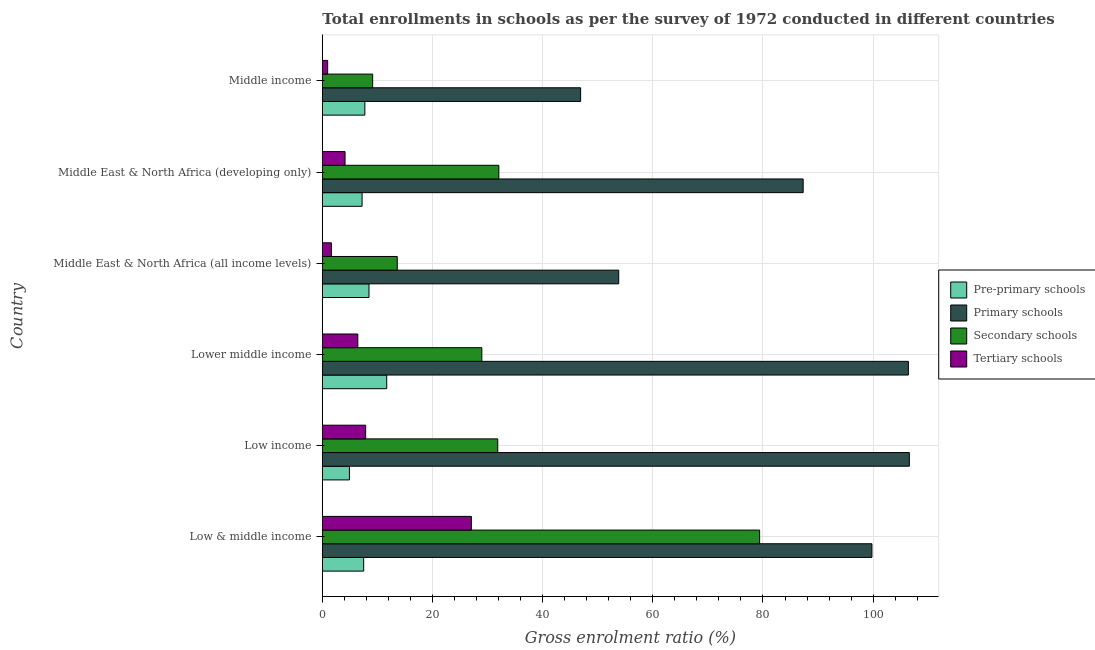How many different coloured bars are there?
Your answer should be very brief. 4. Are the number of bars on each tick of the Y-axis equal?
Your answer should be compact. Yes. How many bars are there on the 5th tick from the bottom?
Provide a short and direct response. 4. What is the label of the 3rd group of bars from the top?
Provide a succinct answer. Middle East & North Africa (all income levels). In how many cases, is the number of bars for a given country not equal to the number of legend labels?
Your answer should be compact. 0. What is the gross enrolment ratio in secondary schools in Middle income?
Provide a succinct answer. 9.14. Across all countries, what is the maximum gross enrolment ratio in primary schools?
Offer a terse response. 106.58. Across all countries, what is the minimum gross enrolment ratio in secondary schools?
Provide a succinct answer. 9.14. In which country was the gross enrolment ratio in tertiary schools maximum?
Give a very brief answer. Low & middle income. What is the total gross enrolment ratio in primary schools in the graph?
Offer a terse response. 500.77. What is the difference between the gross enrolment ratio in secondary schools in Low & middle income and that in Lower middle income?
Make the answer very short. 50.44. What is the difference between the gross enrolment ratio in primary schools in Lower middle income and the gross enrolment ratio in secondary schools in Low income?
Make the answer very short. 74.55. What is the average gross enrolment ratio in primary schools per country?
Your answer should be compact. 83.46. What is the difference between the gross enrolment ratio in primary schools and gross enrolment ratio in secondary schools in Low income?
Give a very brief answer. 74.73. In how many countries, is the gross enrolment ratio in pre-primary schools greater than 80 %?
Offer a terse response. 0. What is the ratio of the gross enrolment ratio in secondary schools in Low income to that in Middle East & North Africa (all income levels)?
Offer a very short reply. 2.34. What is the difference between the highest and the second highest gross enrolment ratio in primary schools?
Offer a terse response. 0.17. What is the difference between the highest and the lowest gross enrolment ratio in primary schools?
Your answer should be compact. 59.68. In how many countries, is the gross enrolment ratio in primary schools greater than the average gross enrolment ratio in primary schools taken over all countries?
Your response must be concise. 4. Is the sum of the gross enrolment ratio in pre-primary schools in Low income and Middle East & North Africa (all income levels) greater than the maximum gross enrolment ratio in secondary schools across all countries?
Ensure brevity in your answer.  No. What does the 3rd bar from the top in Lower middle income represents?
Provide a succinct answer. Primary schools. What does the 4th bar from the bottom in Middle income represents?
Provide a short and direct response. Tertiary schools. Is it the case that in every country, the sum of the gross enrolment ratio in pre-primary schools and gross enrolment ratio in primary schools is greater than the gross enrolment ratio in secondary schools?
Your answer should be very brief. Yes. How many bars are there?
Keep it short and to the point. 24. Are all the bars in the graph horizontal?
Your answer should be very brief. Yes. How many countries are there in the graph?
Keep it short and to the point. 6. What is the difference between two consecutive major ticks on the X-axis?
Keep it short and to the point. 20. Are the values on the major ticks of X-axis written in scientific E-notation?
Provide a short and direct response. No. Does the graph contain grids?
Make the answer very short. Yes. Where does the legend appear in the graph?
Ensure brevity in your answer.  Center right. How are the legend labels stacked?
Provide a succinct answer. Vertical. What is the title of the graph?
Provide a succinct answer. Total enrollments in schools as per the survey of 1972 conducted in different countries. What is the Gross enrolment ratio (%) of Pre-primary schools in Low & middle income?
Your answer should be compact. 7.51. What is the Gross enrolment ratio (%) of Primary schools in Low & middle income?
Provide a succinct answer. 99.78. What is the Gross enrolment ratio (%) of Secondary schools in Low & middle income?
Provide a succinct answer. 79.39. What is the Gross enrolment ratio (%) in Tertiary schools in Low & middle income?
Ensure brevity in your answer.  27.06. What is the Gross enrolment ratio (%) in Pre-primary schools in Low income?
Provide a short and direct response. 4.92. What is the Gross enrolment ratio (%) of Primary schools in Low income?
Provide a succinct answer. 106.58. What is the Gross enrolment ratio (%) of Secondary schools in Low income?
Offer a very short reply. 31.85. What is the Gross enrolment ratio (%) of Tertiary schools in Low income?
Provide a short and direct response. 7.87. What is the Gross enrolment ratio (%) of Pre-primary schools in Lower middle income?
Your answer should be compact. 11.69. What is the Gross enrolment ratio (%) of Primary schools in Lower middle income?
Provide a succinct answer. 106.4. What is the Gross enrolment ratio (%) in Secondary schools in Lower middle income?
Give a very brief answer. 28.95. What is the Gross enrolment ratio (%) in Tertiary schools in Lower middle income?
Your answer should be very brief. 6.44. What is the Gross enrolment ratio (%) in Pre-primary schools in Middle East & North Africa (all income levels)?
Make the answer very short. 8.47. What is the Gross enrolment ratio (%) of Primary schools in Middle East & North Africa (all income levels)?
Keep it short and to the point. 53.81. What is the Gross enrolment ratio (%) of Secondary schools in Middle East & North Africa (all income levels)?
Keep it short and to the point. 13.61. What is the Gross enrolment ratio (%) of Tertiary schools in Middle East & North Africa (all income levels)?
Ensure brevity in your answer.  1.65. What is the Gross enrolment ratio (%) in Pre-primary schools in Middle East & North Africa (developing only)?
Make the answer very short. 7.22. What is the Gross enrolment ratio (%) in Primary schools in Middle East & North Africa (developing only)?
Give a very brief answer. 87.3. What is the Gross enrolment ratio (%) of Secondary schools in Middle East & North Africa (developing only)?
Ensure brevity in your answer.  32.04. What is the Gross enrolment ratio (%) in Tertiary schools in Middle East & North Africa (developing only)?
Offer a very short reply. 4.13. What is the Gross enrolment ratio (%) in Pre-primary schools in Middle income?
Your answer should be very brief. 7.72. What is the Gross enrolment ratio (%) of Primary schools in Middle income?
Give a very brief answer. 46.89. What is the Gross enrolment ratio (%) in Secondary schools in Middle income?
Your response must be concise. 9.14. What is the Gross enrolment ratio (%) in Tertiary schools in Middle income?
Offer a very short reply. 0.97. Across all countries, what is the maximum Gross enrolment ratio (%) in Pre-primary schools?
Provide a short and direct response. 11.69. Across all countries, what is the maximum Gross enrolment ratio (%) in Primary schools?
Offer a terse response. 106.58. Across all countries, what is the maximum Gross enrolment ratio (%) in Secondary schools?
Offer a terse response. 79.39. Across all countries, what is the maximum Gross enrolment ratio (%) of Tertiary schools?
Offer a terse response. 27.06. Across all countries, what is the minimum Gross enrolment ratio (%) in Pre-primary schools?
Make the answer very short. 4.92. Across all countries, what is the minimum Gross enrolment ratio (%) in Primary schools?
Give a very brief answer. 46.89. Across all countries, what is the minimum Gross enrolment ratio (%) in Secondary schools?
Your answer should be very brief. 9.14. Across all countries, what is the minimum Gross enrolment ratio (%) of Tertiary schools?
Provide a short and direct response. 0.97. What is the total Gross enrolment ratio (%) in Pre-primary schools in the graph?
Your response must be concise. 47.53. What is the total Gross enrolment ratio (%) of Primary schools in the graph?
Your response must be concise. 500.77. What is the total Gross enrolment ratio (%) of Secondary schools in the graph?
Make the answer very short. 194.99. What is the total Gross enrolment ratio (%) in Tertiary schools in the graph?
Offer a terse response. 48.12. What is the difference between the Gross enrolment ratio (%) of Pre-primary schools in Low & middle income and that in Low income?
Offer a very short reply. 2.59. What is the difference between the Gross enrolment ratio (%) of Primary schools in Low & middle income and that in Low income?
Your response must be concise. -6.79. What is the difference between the Gross enrolment ratio (%) of Secondary schools in Low & middle income and that in Low income?
Keep it short and to the point. 47.54. What is the difference between the Gross enrolment ratio (%) of Tertiary schools in Low & middle income and that in Low income?
Your answer should be compact. 19.2. What is the difference between the Gross enrolment ratio (%) of Pre-primary schools in Low & middle income and that in Lower middle income?
Provide a succinct answer. -4.18. What is the difference between the Gross enrolment ratio (%) of Primary schools in Low & middle income and that in Lower middle income?
Your answer should be compact. -6.62. What is the difference between the Gross enrolment ratio (%) of Secondary schools in Low & middle income and that in Lower middle income?
Offer a terse response. 50.44. What is the difference between the Gross enrolment ratio (%) of Tertiary schools in Low & middle income and that in Lower middle income?
Provide a short and direct response. 20.62. What is the difference between the Gross enrolment ratio (%) of Pre-primary schools in Low & middle income and that in Middle East & North Africa (all income levels)?
Provide a short and direct response. -0.96. What is the difference between the Gross enrolment ratio (%) in Primary schools in Low & middle income and that in Middle East & North Africa (all income levels)?
Provide a short and direct response. 45.97. What is the difference between the Gross enrolment ratio (%) in Secondary schools in Low & middle income and that in Middle East & North Africa (all income levels)?
Provide a succinct answer. 65.79. What is the difference between the Gross enrolment ratio (%) in Tertiary schools in Low & middle income and that in Middle East & North Africa (all income levels)?
Provide a succinct answer. 25.42. What is the difference between the Gross enrolment ratio (%) in Pre-primary schools in Low & middle income and that in Middle East & North Africa (developing only)?
Offer a very short reply. 0.29. What is the difference between the Gross enrolment ratio (%) in Primary schools in Low & middle income and that in Middle East & North Africa (developing only)?
Offer a terse response. 12.48. What is the difference between the Gross enrolment ratio (%) in Secondary schools in Low & middle income and that in Middle East & North Africa (developing only)?
Ensure brevity in your answer.  47.35. What is the difference between the Gross enrolment ratio (%) in Tertiary schools in Low & middle income and that in Middle East & North Africa (developing only)?
Make the answer very short. 22.94. What is the difference between the Gross enrolment ratio (%) in Pre-primary schools in Low & middle income and that in Middle income?
Your answer should be compact. -0.21. What is the difference between the Gross enrolment ratio (%) of Primary schools in Low & middle income and that in Middle income?
Give a very brief answer. 52.89. What is the difference between the Gross enrolment ratio (%) of Secondary schools in Low & middle income and that in Middle income?
Your answer should be compact. 70.26. What is the difference between the Gross enrolment ratio (%) of Tertiary schools in Low & middle income and that in Middle income?
Your response must be concise. 26.1. What is the difference between the Gross enrolment ratio (%) in Pre-primary schools in Low income and that in Lower middle income?
Keep it short and to the point. -6.77. What is the difference between the Gross enrolment ratio (%) in Primary schools in Low income and that in Lower middle income?
Make the answer very short. 0.17. What is the difference between the Gross enrolment ratio (%) of Secondary schools in Low income and that in Lower middle income?
Give a very brief answer. 2.9. What is the difference between the Gross enrolment ratio (%) of Tertiary schools in Low income and that in Lower middle income?
Your response must be concise. 1.43. What is the difference between the Gross enrolment ratio (%) of Pre-primary schools in Low income and that in Middle East & North Africa (all income levels)?
Provide a short and direct response. -3.55. What is the difference between the Gross enrolment ratio (%) in Primary schools in Low income and that in Middle East & North Africa (all income levels)?
Make the answer very short. 52.77. What is the difference between the Gross enrolment ratio (%) in Secondary schools in Low income and that in Middle East & North Africa (all income levels)?
Ensure brevity in your answer.  18.24. What is the difference between the Gross enrolment ratio (%) of Tertiary schools in Low income and that in Middle East & North Africa (all income levels)?
Your response must be concise. 6.22. What is the difference between the Gross enrolment ratio (%) of Pre-primary schools in Low income and that in Middle East & North Africa (developing only)?
Offer a very short reply. -2.3. What is the difference between the Gross enrolment ratio (%) of Primary schools in Low income and that in Middle East & North Africa (developing only)?
Give a very brief answer. 19.28. What is the difference between the Gross enrolment ratio (%) in Secondary schools in Low income and that in Middle East & North Africa (developing only)?
Your response must be concise. -0.2. What is the difference between the Gross enrolment ratio (%) in Tertiary schools in Low income and that in Middle East & North Africa (developing only)?
Give a very brief answer. 3.74. What is the difference between the Gross enrolment ratio (%) in Pre-primary schools in Low income and that in Middle income?
Keep it short and to the point. -2.8. What is the difference between the Gross enrolment ratio (%) in Primary schools in Low income and that in Middle income?
Your response must be concise. 59.68. What is the difference between the Gross enrolment ratio (%) in Secondary schools in Low income and that in Middle income?
Your response must be concise. 22.71. What is the difference between the Gross enrolment ratio (%) of Tertiary schools in Low income and that in Middle income?
Your response must be concise. 6.9. What is the difference between the Gross enrolment ratio (%) of Pre-primary schools in Lower middle income and that in Middle East & North Africa (all income levels)?
Offer a very short reply. 3.22. What is the difference between the Gross enrolment ratio (%) in Primary schools in Lower middle income and that in Middle East & North Africa (all income levels)?
Give a very brief answer. 52.59. What is the difference between the Gross enrolment ratio (%) in Secondary schools in Lower middle income and that in Middle East & North Africa (all income levels)?
Keep it short and to the point. 15.35. What is the difference between the Gross enrolment ratio (%) in Tertiary schools in Lower middle income and that in Middle East & North Africa (all income levels)?
Your answer should be very brief. 4.8. What is the difference between the Gross enrolment ratio (%) of Pre-primary schools in Lower middle income and that in Middle East & North Africa (developing only)?
Your response must be concise. 4.48. What is the difference between the Gross enrolment ratio (%) of Primary schools in Lower middle income and that in Middle East & North Africa (developing only)?
Your answer should be compact. 19.1. What is the difference between the Gross enrolment ratio (%) of Secondary schools in Lower middle income and that in Middle East & North Africa (developing only)?
Your answer should be compact. -3.09. What is the difference between the Gross enrolment ratio (%) of Tertiary schools in Lower middle income and that in Middle East & North Africa (developing only)?
Keep it short and to the point. 2.32. What is the difference between the Gross enrolment ratio (%) in Pre-primary schools in Lower middle income and that in Middle income?
Make the answer very short. 3.97. What is the difference between the Gross enrolment ratio (%) in Primary schools in Lower middle income and that in Middle income?
Ensure brevity in your answer.  59.51. What is the difference between the Gross enrolment ratio (%) of Secondary schools in Lower middle income and that in Middle income?
Offer a terse response. 19.82. What is the difference between the Gross enrolment ratio (%) of Tertiary schools in Lower middle income and that in Middle income?
Offer a very short reply. 5.47. What is the difference between the Gross enrolment ratio (%) in Pre-primary schools in Middle East & North Africa (all income levels) and that in Middle East & North Africa (developing only)?
Offer a terse response. 1.26. What is the difference between the Gross enrolment ratio (%) of Primary schools in Middle East & North Africa (all income levels) and that in Middle East & North Africa (developing only)?
Make the answer very short. -33.49. What is the difference between the Gross enrolment ratio (%) of Secondary schools in Middle East & North Africa (all income levels) and that in Middle East & North Africa (developing only)?
Offer a very short reply. -18.44. What is the difference between the Gross enrolment ratio (%) of Tertiary schools in Middle East & North Africa (all income levels) and that in Middle East & North Africa (developing only)?
Your answer should be very brief. -2.48. What is the difference between the Gross enrolment ratio (%) of Pre-primary schools in Middle East & North Africa (all income levels) and that in Middle income?
Provide a short and direct response. 0.75. What is the difference between the Gross enrolment ratio (%) in Primary schools in Middle East & North Africa (all income levels) and that in Middle income?
Your answer should be compact. 6.92. What is the difference between the Gross enrolment ratio (%) of Secondary schools in Middle East & North Africa (all income levels) and that in Middle income?
Your answer should be very brief. 4.47. What is the difference between the Gross enrolment ratio (%) in Tertiary schools in Middle East & North Africa (all income levels) and that in Middle income?
Ensure brevity in your answer.  0.68. What is the difference between the Gross enrolment ratio (%) of Pre-primary schools in Middle East & North Africa (developing only) and that in Middle income?
Your answer should be very brief. -0.51. What is the difference between the Gross enrolment ratio (%) of Primary schools in Middle East & North Africa (developing only) and that in Middle income?
Give a very brief answer. 40.4. What is the difference between the Gross enrolment ratio (%) in Secondary schools in Middle East & North Africa (developing only) and that in Middle income?
Make the answer very short. 22.91. What is the difference between the Gross enrolment ratio (%) in Tertiary schools in Middle East & North Africa (developing only) and that in Middle income?
Your answer should be very brief. 3.16. What is the difference between the Gross enrolment ratio (%) of Pre-primary schools in Low & middle income and the Gross enrolment ratio (%) of Primary schools in Low income?
Your response must be concise. -99.07. What is the difference between the Gross enrolment ratio (%) of Pre-primary schools in Low & middle income and the Gross enrolment ratio (%) of Secondary schools in Low income?
Your answer should be compact. -24.34. What is the difference between the Gross enrolment ratio (%) of Pre-primary schools in Low & middle income and the Gross enrolment ratio (%) of Tertiary schools in Low income?
Make the answer very short. -0.36. What is the difference between the Gross enrolment ratio (%) of Primary schools in Low & middle income and the Gross enrolment ratio (%) of Secondary schools in Low income?
Provide a succinct answer. 67.93. What is the difference between the Gross enrolment ratio (%) in Primary schools in Low & middle income and the Gross enrolment ratio (%) in Tertiary schools in Low income?
Your response must be concise. 91.92. What is the difference between the Gross enrolment ratio (%) in Secondary schools in Low & middle income and the Gross enrolment ratio (%) in Tertiary schools in Low income?
Offer a very short reply. 71.53. What is the difference between the Gross enrolment ratio (%) of Pre-primary schools in Low & middle income and the Gross enrolment ratio (%) of Primary schools in Lower middle income?
Your answer should be compact. -98.89. What is the difference between the Gross enrolment ratio (%) in Pre-primary schools in Low & middle income and the Gross enrolment ratio (%) in Secondary schools in Lower middle income?
Your answer should be very brief. -21.44. What is the difference between the Gross enrolment ratio (%) in Pre-primary schools in Low & middle income and the Gross enrolment ratio (%) in Tertiary schools in Lower middle income?
Keep it short and to the point. 1.07. What is the difference between the Gross enrolment ratio (%) of Primary schools in Low & middle income and the Gross enrolment ratio (%) of Secondary schools in Lower middle income?
Offer a terse response. 70.83. What is the difference between the Gross enrolment ratio (%) of Primary schools in Low & middle income and the Gross enrolment ratio (%) of Tertiary schools in Lower middle income?
Your answer should be very brief. 93.34. What is the difference between the Gross enrolment ratio (%) of Secondary schools in Low & middle income and the Gross enrolment ratio (%) of Tertiary schools in Lower middle income?
Ensure brevity in your answer.  72.95. What is the difference between the Gross enrolment ratio (%) of Pre-primary schools in Low & middle income and the Gross enrolment ratio (%) of Primary schools in Middle East & North Africa (all income levels)?
Your response must be concise. -46.3. What is the difference between the Gross enrolment ratio (%) of Pre-primary schools in Low & middle income and the Gross enrolment ratio (%) of Secondary schools in Middle East & North Africa (all income levels)?
Your response must be concise. -6.1. What is the difference between the Gross enrolment ratio (%) in Pre-primary schools in Low & middle income and the Gross enrolment ratio (%) in Tertiary schools in Middle East & North Africa (all income levels)?
Provide a succinct answer. 5.86. What is the difference between the Gross enrolment ratio (%) of Primary schools in Low & middle income and the Gross enrolment ratio (%) of Secondary schools in Middle East & North Africa (all income levels)?
Your answer should be very brief. 86.18. What is the difference between the Gross enrolment ratio (%) of Primary schools in Low & middle income and the Gross enrolment ratio (%) of Tertiary schools in Middle East & North Africa (all income levels)?
Your answer should be compact. 98.14. What is the difference between the Gross enrolment ratio (%) of Secondary schools in Low & middle income and the Gross enrolment ratio (%) of Tertiary schools in Middle East & North Africa (all income levels)?
Provide a short and direct response. 77.75. What is the difference between the Gross enrolment ratio (%) of Pre-primary schools in Low & middle income and the Gross enrolment ratio (%) of Primary schools in Middle East & North Africa (developing only)?
Offer a terse response. -79.79. What is the difference between the Gross enrolment ratio (%) of Pre-primary schools in Low & middle income and the Gross enrolment ratio (%) of Secondary schools in Middle East & North Africa (developing only)?
Your response must be concise. -24.54. What is the difference between the Gross enrolment ratio (%) in Pre-primary schools in Low & middle income and the Gross enrolment ratio (%) in Tertiary schools in Middle East & North Africa (developing only)?
Your answer should be very brief. 3.38. What is the difference between the Gross enrolment ratio (%) of Primary schools in Low & middle income and the Gross enrolment ratio (%) of Secondary schools in Middle East & North Africa (developing only)?
Give a very brief answer. 67.74. What is the difference between the Gross enrolment ratio (%) of Primary schools in Low & middle income and the Gross enrolment ratio (%) of Tertiary schools in Middle East & North Africa (developing only)?
Your response must be concise. 95.66. What is the difference between the Gross enrolment ratio (%) of Secondary schools in Low & middle income and the Gross enrolment ratio (%) of Tertiary schools in Middle East & North Africa (developing only)?
Make the answer very short. 75.27. What is the difference between the Gross enrolment ratio (%) of Pre-primary schools in Low & middle income and the Gross enrolment ratio (%) of Primary schools in Middle income?
Provide a succinct answer. -39.38. What is the difference between the Gross enrolment ratio (%) in Pre-primary schools in Low & middle income and the Gross enrolment ratio (%) in Secondary schools in Middle income?
Give a very brief answer. -1.63. What is the difference between the Gross enrolment ratio (%) of Pre-primary schools in Low & middle income and the Gross enrolment ratio (%) of Tertiary schools in Middle income?
Offer a terse response. 6.54. What is the difference between the Gross enrolment ratio (%) in Primary schools in Low & middle income and the Gross enrolment ratio (%) in Secondary schools in Middle income?
Offer a terse response. 90.64. What is the difference between the Gross enrolment ratio (%) in Primary schools in Low & middle income and the Gross enrolment ratio (%) in Tertiary schools in Middle income?
Your response must be concise. 98.81. What is the difference between the Gross enrolment ratio (%) of Secondary schools in Low & middle income and the Gross enrolment ratio (%) of Tertiary schools in Middle income?
Your response must be concise. 78.43. What is the difference between the Gross enrolment ratio (%) in Pre-primary schools in Low income and the Gross enrolment ratio (%) in Primary schools in Lower middle income?
Your answer should be very brief. -101.48. What is the difference between the Gross enrolment ratio (%) of Pre-primary schools in Low income and the Gross enrolment ratio (%) of Secondary schools in Lower middle income?
Your answer should be compact. -24.04. What is the difference between the Gross enrolment ratio (%) of Pre-primary schools in Low income and the Gross enrolment ratio (%) of Tertiary schools in Lower middle income?
Give a very brief answer. -1.52. What is the difference between the Gross enrolment ratio (%) in Primary schools in Low income and the Gross enrolment ratio (%) in Secondary schools in Lower middle income?
Offer a very short reply. 77.62. What is the difference between the Gross enrolment ratio (%) of Primary schools in Low income and the Gross enrolment ratio (%) of Tertiary schools in Lower middle income?
Your answer should be compact. 100.13. What is the difference between the Gross enrolment ratio (%) of Secondary schools in Low income and the Gross enrolment ratio (%) of Tertiary schools in Lower middle income?
Offer a terse response. 25.41. What is the difference between the Gross enrolment ratio (%) in Pre-primary schools in Low income and the Gross enrolment ratio (%) in Primary schools in Middle East & North Africa (all income levels)?
Keep it short and to the point. -48.89. What is the difference between the Gross enrolment ratio (%) in Pre-primary schools in Low income and the Gross enrolment ratio (%) in Secondary schools in Middle East & North Africa (all income levels)?
Make the answer very short. -8.69. What is the difference between the Gross enrolment ratio (%) of Pre-primary schools in Low income and the Gross enrolment ratio (%) of Tertiary schools in Middle East & North Africa (all income levels)?
Provide a short and direct response. 3.27. What is the difference between the Gross enrolment ratio (%) in Primary schools in Low income and the Gross enrolment ratio (%) in Secondary schools in Middle East & North Africa (all income levels)?
Offer a very short reply. 92.97. What is the difference between the Gross enrolment ratio (%) in Primary schools in Low income and the Gross enrolment ratio (%) in Tertiary schools in Middle East & North Africa (all income levels)?
Make the answer very short. 104.93. What is the difference between the Gross enrolment ratio (%) in Secondary schools in Low income and the Gross enrolment ratio (%) in Tertiary schools in Middle East & North Africa (all income levels)?
Your answer should be compact. 30.2. What is the difference between the Gross enrolment ratio (%) in Pre-primary schools in Low income and the Gross enrolment ratio (%) in Primary schools in Middle East & North Africa (developing only)?
Offer a very short reply. -82.38. What is the difference between the Gross enrolment ratio (%) of Pre-primary schools in Low income and the Gross enrolment ratio (%) of Secondary schools in Middle East & North Africa (developing only)?
Give a very brief answer. -27.13. What is the difference between the Gross enrolment ratio (%) of Pre-primary schools in Low income and the Gross enrolment ratio (%) of Tertiary schools in Middle East & North Africa (developing only)?
Make the answer very short. 0.79. What is the difference between the Gross enrolment ratio (%) in Primary schools in Low income and the Gross enrolment ratio (%) in Secondary schools in Middle East & North Africa (developing only)?
Give a very brief answer. 74.53. What is the difference between the Gross enrolment ratio (%) in Primary schools in Low income and the Gross enrolment ratio (%) in Tertiary schools in Middle East & North Africa (developing only)?
Give a very brief answer. 102.45. What is the difference between the Gross enrolment ratio (%) of Secondary schools in Low income and the Gross enrolment ratio (%) of Tertiary schools in Middle East & North Africa (developing only)?
Provide a short and direct response. 27.72. What is the difference between the Gross enrolment ratio (%) in Pre-primary schools in Low income and the Gross enrolment ratio (%) in Primary schools in Middle income?
Provide a succinct answer. -41.98. What is the difference between the Gross enrolment ratio (%) in Pre-primary schools in Low income and the Gross enrolment ratio (%) in Secondary schools in Middle income?
Your answer should be compact. -4.22. What is the difference between the Gross enrolment ratio (%) in Pre-primary schools in Low income and the Gross enrolment ratio (%) in Tertiary schools in Middle income?
Provide a short and direct response. 3.95. What is the difference between the Gross enrolment ratio (%) of Primary schools in Low income and the Gross enrolment ratio (%) of Secondary schools in Middle income?
Keep it short and to the point. 97.44. What is the difference between the Gross enrolment ratio (%) of Primary schools in Low income and the Gross enrolment ratio (%) of Tertiary schools in Middle income?
Provide a succinct answer. 105.61. What is the difference between the Gross enrolment ratio (%) in Secondary schools in Low income and the Gross enrolment ratio (%) in Tertiary schools in Middle income?
Provide a succinct answer. 30.88. What is the difference between the Gross enrolment ratio (%) of Pre-primary schools in Lower middle income and the Gross enrolment ratio (%) of Primary schools in Middle East & North Africa (all income levels)?
Provide a short and direct response. -42.12. What is the difference between the Gross enrolment ratio (%) of Pre-primary schools in Lower middle income and the Gross enrolment ratio (%) of Secondary schools in Middle East & North Africa (all income levels)?
Your response must be concise. -1.91. What is the difference between the Gross enrolment ratio (%) in Pre-primary schools in Lower middle income and the Gross enrolment ratio (%) in Tertiary schools in Middle East & North Africa (all income levels)?
Make the answer very short. 10.04. What is the difference between the Gross enrolment ratio (%) in Primary schools in Lower middle income and the Gross enrolment ratio (%) in Secondary schools in Middle East & North Africa (all income levels)?
Make the answer very short. 92.8. What is the difference between the Gross enrolment ratio (%) in Primary schools in Lower middle income and the Gross enrolment ratio (%) in Tertiary schools in Middle East & North Africa (all income levels)?
Your answer should be compact. 104.76. What is the difference between the Gross enrolment ratio (%) in Secondary schools in Lower middle income and the Gross enrolment ratio (%) in Tertiary schools in Middle East & North Africa (all income levels)?
Provide a short and direct response. 27.31. What is the difference between the Gross enrolment ratio (%) of Pre-primary schools in Lower middle income and the Gross enrolment ratio (%) of Primary schools in Middle East & North Africa (developing only)?
Give a very brief answer. -75.61. What is the difference between the Gross enrolment ratio (%) in Pre-primary schools in Lower middle income and the Gross enrolment ratio (%) in Secondary schools in Middle East & North Africa (developing only)?
Your response must be concise. -20.35. What is the difference between the Gross enrolment ratio (%) in Pre-primary schools in Lower middle income and the Gross enrolment ratio (%) in Tertiary schools in Middle East & North Africa (developing only)?
Provide a succinct answer. 7.56. What is the difference between the Gross enrolment ratio (%) in Primary schools in Lower middle income and the Gross enrolment ratio (%) in Secondary schools in Middle East & North Africa (developing only)?
Provide a short and direct response. 74.36. What is the difference between the Gross enrolment ratio (%) of Primary schools in Lower middle income and the Gross enrolment ratio (%) of Tertiary schools in Middle East & North Africa (developing only)?
Provide a short and direct response. 102.28. What is the difference between the Gross enrolment ratio (%) of Secondary schools in Lower middle income and the Gross enrolment ratio (%) of Tertiary schools in Middle East & North Africa (developing only)?
Keep it short and to the point. 24.83. What is the difference between the Gross enrolment ratio (%) in Pre-primary schools in Lower middle income and the Gross enrolment ratio (%) in Primary schools in Middle income?
Give a very brief answer. -35.2. What is the difference between the Gross enrolment ratio (%) in Pre-primary schools in Lower middle income and the Gross enrolment ratio (%) in Secondary schools in Middle income?
Provide a succinct answer. 2.55. What is the difference between the Gross enrolment ratio (%) of Pre-primary schools in Lower middle income and the Gross enrolment ratio (%) of Tertiary schools in Middle income?
Your answer should be compact. 10.72. What is the difference between the Gross enrolment ratio (%) in Primary schools in Lower middle income and the Gross enrolment ratio (%) in Secondary schools in Middle income?
Offer a very short reply. 97.26. What is the difference between the Gross enrolment ratio (%) of Primary schools in Lower middle income and the Gross enrolment ratio (%) of Tertiary schools in Middle income?
Your answer should be very brief. 105.43. What is the difference between the Gross enrolment ratio (%) in Secondary schools in Lower middle income and the Gross enrolment ratio (%) in Tertiary schools in Middle income?
Offer a very short reply. 27.99. What is the difference between the Gross enrolment ratio (%) of Pre-primary schools in Middle East & North Africa (all income levels) and the Gross enrolment ratio (%) of Primary schools in Middle East & North Africa (developing only)?
Your answer should be compact. -78.83. What is the difference between the Gross enrolment ratio (%) in Pre-primary schools in Middle East & North Africa (all income levels) and the Gross enrolment ratio (%) in Secondary schools in Middle East & North Africa (developing only)?
Your answer should be compact. -23.57. What is the difference between the Gross enrolment ratio (%) of Pre-primary schools in Middle East & North Africa (all income levels) and the Gross enrolment ratio (%) of Tertiary schools in Middle East & North Africa (developing only)?
Provide a short and direct response. 4.35. What is the difference between the Gross enrolment ratio (%) in Primary schools in Middle East & North Africa (all income levels) and the Gross enrolment ratio (%) in Secondary schools in Middle East & North Africa (developing only)?
Your response must be concise. 21.77. What is the difference between the Gross enrolment ratio (%) in Primary schools in Middle East & North Africa (all income levels) and the Gross enrolment ratio (%) in Tertiary schools in Middle East & North Africa (developing only)?
Keep it short and to the point. 49.68. What is the difference between the Gross enrolment ratio (%) in Secondary schools in Middle East & North Africa (all income levels) and the Gross enrolment ratio (%) in Tertiary schools in Middle East & North Africa (developing only)?
Ensure brevity in your answer.  9.48. What is the difference between the Gross enrolment ratio (%) in Pre-primary schools in Middle East & North Africa (all income levels) and the Gross enrolment ratio (%) in Primary schools in Middle income?
Your answer should be very brief. -38.42. What is the difference between the Gross enrolment ratio (%) of Pre-primary schools in Middle East & North Africa (all income levels) and the Gross enrolment ratio (%) of Secondary schools in Middle income?
Your answer should be compact. -0.67. What is the difference between the Gross enrolment ratio (%) in Pre-primary schools in Middle East & North Africa (all income levels) and the Gross enrolment ratio (%) in Tertiary schools in Middle income?
Offer a very short reply. 7.5. What is the difference between the Gross enrolment ratio (%) in Primary schools in Middle East & North Africa (all income levels) and the Gross enrolment ratio (%) in Secondary schools in Middle income?
Offer a very short reply. 44.67. What is the difference between the Gross enrolment ratio (%) in Primary schools in Middle East & North Africa (all income levels) and the Gross enrolment ratio (%) in Tertiary schools in Middle income?
Your answer should be very brief. 52.84. What is the difference between the Gross enrolment ratio (%) in Secondary schools in Middle East & North Africa (all income levels) and the Gross enrolment ratio (%) in Tertiary schools in Middle income?
Your response must be concise. 12.64. What is the difference between the Gross enrolment ratio (%) of Pre-primary schools in Middle East & North Africa (developing only) and the Gross enrolment ratio (%) of Primary schools in Middle income?
Your response must be concise. -39.68. What is the difference between the Gross enrolment ratio (%) in Pre-primary schools in Middle East & North Africa (developing only) and the Gross enrolment ratio (%) in Secondary schools in Middle income?
Make the answer very short. -1.92. What is the difference between the Gross enrolment ratio (%) in Pre-primary schools in Middle East & North Africa (developing only) and the Gross enrolment ratio (%) in Tertiary schools in Middle income?
Make the answer very short. 6.25. What is the difference between the Gross enrolment ratio (%) of Primary schools in Middle East & North Africa (developing only) and the Gross enrolment ratio (%) of Secondary schools in Middle income?
Provide a short and direct response. 78.16. What is the difference between the Gross enrolment ratio (%) in Primary schools in Middle East & North Africa (developing only) and the Gross enrolment ratio (%) in Tertiary schools in Middle income?
Provide a succinct answer. 86.33. What is the difference between the Gross enrolment ratio (%) in Secondary schools in Middle East & North Africa (developing only) and the Gross enrolment ratio (%) in Tertiary schools in Middle income?
Make the answer very short. 31.08. What is the average Gross enrolment ratio (%) of Pre-primary schools per country?
Keep it short and to the point. 7.92. What is the average Gross enrolment ratio (%) of Primary schools per country?
Your response must be concise. 83.46. What is the average Gross enrolment ratio (%) of Secondary schools per country?
Offer a terse response. 32.5. What is the average Gross enrolment ratio (%) of Tertiary schools per country?
Make the answer very short. 8.02. What is the difference between the Gross enrolment ratio (%) in Pre-primary schools and Gross enrolment ratio (%) in Primary schools in Low & middle income?
Ensure brevity in your answer.  -92.27. What is the difference between the Gross enrolment ratio (%) in Pre-primary schools and Gross enrolment ratio (%) in Secondary schools in Low & middle income?
Make the answer very short. -71.88. What is the difference between the Gross enrolment ratio (%) of Pre-primary schools and Gross enrolment ratio (%) of Tertiary schools in Low & middle income?
Keep it short and to the point. -19.55. What is the difference between the Gross enrolment ratio (%) of Primary schools and Gross enrolment ratio (%) of Secondary schools in Low & middle income?
Your response must be concise. 20.39. What is the difference between the Gross enrolment ratio (%) of Primary schools and Gross enrolment ratio (%) of Tertiary schools in Low & middle income?
Your answer should be compact. 72.72. What is the difference between the Gross enrolment ratio (%) of Secondary schools and Gross enrolment ratio (%) of Tertiary schools in Low & middle income?
Provide a short and direct response. 52.33. What is the difference between the Gross enrolment ratio (%) in Pre-primary schools and Gross enrolment ratio (%) in Primary schools in Low income?
Offer a very short reply. -101.66. What is the difference between the Gross enrolment ratio (%) in Pre-primary schools and Gross enrolment ratio (%) in Secondary schools in Low income?
Ensure brevity in your answer.  -26.93. What is the difference between the Gross enrolment ratio (%) of Pre-primary schools and Gross enrolment ratio (%) of Tertiary schools in Low income?
Offer a very short reply. -2.95. What is the difference between the Gross enrolment ratio (%) in Primary schools and Gross enrolment ratio (%) in Secondary schools in Low income?
Make the answer very short. 74.73. What is the difference between the Gross enrolment ratio (%) in Primary schools and Gross enrolment ratio (%) in Tertiary schools in Low income?
Make the answer very short. 98.71. What is the difference between the Gross enrolment ratio (%) of Secondary schools and Gross enrolment ratio (%) of Tertiary schools in Low income?
Provide a short and direct response. 23.98. What is the difference between the Gross enrolment ratio (%) of Pre-primary schools and Gross enrolment ratio (%) of Primary schools in Lower middle income?
Offer a very short reply. -94.71. What is the difference between the Gross enrolment ratio (%) of Pre-primary schools and Gross enrolment ratio (%) of Secondary schools in Lower middle income?
Offer a very short reply. -17.26. What is the difference between the Gross enrolment ratio (%) in Pre-primary schools and Gross enrolment ratio (%) in Tertiary schools in Lower middle income?
Offer a terse response. 5.25. What is the difference between the Gross enrolment ratio (%) in Primary schools and Gross enrolment ratio (%) in Secondary schools in Lower middle income?
Give a very brief answer. 77.45. What is the difference between the Gross enrolment ratio (%) in Primary schools and Gross enrolment ratio (%) in Tertiary schools in Lower middle income?
Offer a very short reply. 99.96. What is the difference between the Gross enrolment ratio (%) of Secondary schools and Gross enrolment ratio (%) of Tertiary schools in Lower middle income?
Your answer should be very brief. 22.51. What is the difference between the Gross enrolment ratio (%) in Pre-primary schools and Gross enrolment ratio (%) in Primary schools in Middle East & North Africa (all income levels)?
Give a very brief answer. -45.34. What is the difference between the Gross enrolment ratio (%) in Pre-primary schools and Gross enrolment ratio (%) in Secondary schools in Middle East & North Africa (all income levels)?
Offer a very short reply. -5.13. What is the difference between the Gross enrolment ratio (%) in Pre-primary schools and Gross enrolment ratio (%) in Tertiary schools in Middle East & North Africa (all income levels)?
Provide a short and direct response. 6.83. What is the difference between the Gross enrolment ratio (%) in Primary schools and Gross enrolment ratio (%) in Secondary schools in Middle East & North Africa (all income levels)?
Give a very brief answer. 40.21. What is the difference between the Gross enrolment ratio (%) in Primary schools and Gross enrolment ratio (%) in Tertiary schools in Middle East & North Africa (all income levels)?
Offer a very short reply. 52.16. What is the difference between the Gross enrolment ratio (%) of Secondary schools and Gross enrolment ratio (%) of Tertiary schools in Middle East & North Africa (all income levels)?
Ensure brevity in your answer.  11.96. What is the difference between the Gross enrolment ratio (%) of Pre-primary schools and Gross enrolment ratio (%) of Primary schools in Middle East & North Africa (developing only)?
Provide a succinct answer. -80.08. What is the difference between the Gross enrolment ratio (%) in Pre-primary schools and Gross enrolment ratio (%) in Secondary schools in Middle East & North Africa (developing only)?
Give a very brief answer. -24.83. What is the difference between the Gross enrolment ratio (%) in Pre-primary schools and Gross enrolment ratio (%) in Tertiary schools in Middle East & North Africa (developing only)?
Make the answer very short. 3.09. What is the difference between the Gross enrolment ratio (%) in Primary schools and Gross enrolment ratio (%) in Secondary schools in Middle East & North Africa (developing only)?
Your response must be concise. 55.25. What is the difference between the Gross enrolment ratio (%) of Primary schools and Gross enrolment ratio (%) of Tertiary schools in Middle East & North Africa (developing only)?
Keep it short and to the point. 83.17. What is the difference between the Gross enrolment ratio (%) of Secondary schools and Gross enrolment ratio (%) of Tertiary schools in Middle East & North Africa (developing only)?
Provide a short and direct response. 27.92. What is the difference between the Gross enrolment ratio (%) in Pre-primary schools and Gross enrolment ratio (%) in Primary schools in Middle income?
Provide a short and direct response. -39.17. What is the difference between the Gross enrolment ratio (%) of Pre-primary schools and Gross enrolment ratio (%) of Secondary schools in Middle income?
Make the answer very short. -1.42. What is the difference between the Gross enrolment ratio (%) in Pre-primary schools and Gross enrolment ratio (%) in Tertiary schools in Middle income?
Ensure brevity in your answer.  6.75. What is the difference between the Gross enrolment ratio (%) in Primary schools and Gross enrolment ratio (%) in Secondary schools in Middle income?
Keep it short and to the point. 37.76. What is the difference between the Gross enrolment ratio (%) of Primary schools and Gross enrolment ratio (%) of Tertiary schools in Middle income?
Provide a short and direct response. 45.93. What is the difference between the Gross enrolment ratio (%) in Secondary schools and Gross enrolment ratio (%) in Tertiary schools in Middle income?
Your answer should be very brief. 8.17. What is the ratio of the Gross enrolment ratio (%) of Pre-primary schools in Low & middle income to that in Low income?
Offer a terse response. 1.53. What is the ratio of the Gross enrolment ratio (%) of Primary schools in Low & middle income to that in Low income?
Give a very brief answer. 0.94. What is the ratio of the Gross enrolment ratio (%) of Secondary schools in Low & middle income to that in Low income?
Ensure brevity in your answer.  2.49. What is the ratio of the Gross enrolment ratio (%) of Tertiary schools in Low & middle income to that in Low income?
Offer a terse response. 3.44. What is the ratio of the Gross enrolment ratio (%) in Pre-primary schools in Low & middle income to that in Lower middle income?
Make the answer very short. 0.64. What is the ratio of the Gross enrolment ratio (%) of Primary schools in Low & middle income to that in Lower middle income?
Your answer should be compact. 0.94. What is the ratio of the Gross enrolment ratio (%) of Secondary schools in Low & middle income to that in Lower middle income?
Keep it short and to the point. 2.74. What is the ratio of the Gross enrolment ratio (%) of Tertiary schools in Low & middle income to that in Lower middle income?
Keep it short and to the point. 4.2. What is the ratio of the Gross enrolment ratio (%) of Pre-primary schools in Low & middle income to that in Middle East & North Africa (all income levels)?
Provide a short and direct response. 0.89. What is the ratio of the Gross enrolment ratio (%) in Primary schools in Low & middle income to that in Middle East & North Africa (all income levels)?
Make the answer very short. 1.85. What is the ratio of the Gross enrolment ratio (%) in Secondary schools in Low & middle income to that in Middle East & North Africa (all income levels)?
Give a very brief answer. 5.84. What is the ratio of the Gross enrolment ratio (%) in Tertiary schools in Low & middle income to that in Middle East & North Africa (all income levels)?
Your answer should be compact. 16.44. What is the ratio of the Gross enrolment ratio (%) in Pre-primary schools in Low & middle income to that in Middle East & North Africa (developing only)?
Your answer should be compact. 1.04. What is the ratio of the Gross enrolment ratio (%) of Primary schools in Low & middle income to that in Middle East & North Africa (developing only)?
Provide a short and direct response. 1.14. What is the ratio of the Gross enrolment ratio (%) in Secondary schools in Low & middle income to that in Middle East & North Africa (developing only)?
Offer a very short reply. 2.48. What is the ratio of the Gross enrolment ratio (%) in Tertiary schools in Low & middle income to that in Middle East & North Africa (developing only)?
Make the answer very short. 6.56. What is the ratio of the Gross enrolment ratio (%) of Pre-primary schools in Low & middle income to that in Middle income?
Your answer should be compact. 0.97. What is the ratio of the Gross enrolment ratio (%) of Primary schools in Low & middle income to that in Middle income?
Provide a short and direct response. 2.13. What is the ratio of the Gross enrolment ratio (%) of Secondary schools in Low & middle income to that in Middle income?
Your answer should be compact. 8.69. What is the ratio of the Gross enrolment ratio (%) in Tertiary schools in Low & middle income to that in Middle income?
Ensure brevity in your answer.  27.95. What is the ratio of the Gross enrolment ratio (%) of Pre-primary schools in Low income to that in Lower middle income?
Make the answer very short. 0.42. What is the ratio of the Gross enrolment ratio (%) in Secondary schools in Low income to that in Lower middle income?
Your answer should be very brief. 1.1. What is the ratio of the Gross enrolment ratio (%) of Tertiary schools in Low income to that in Lower middle income?
Your response must be concise. 1.22. What is the ratio of the Gross enrolment ratio (%) of Pre-primary schools in Low income to that in Middle East & North Africa (all income levels)?
Offer a very short reply. 0.58. What is the ratio of the Gross enrolment ratio (%) of Primary schools in Low income to that in Middle East & North Africa (all income levels)?
Offer a terse response. 1.98. What is the ratio of the Gross enrolment ratio (%) of Secondary schools in Low income to that in Middle East & North Africa (all income levels)?
Ensure brevity in your answer.  2.34. What is the ratio of the Gross enrolment ratio (%) of Tertiary schools in Low income to that in Middle East & North Africa (all income levels)?
Your answer should be very brief. 4.78. What is the ratio of the Gross enrolment ratio (%) in Pre-primary schools in Low income to that in Middle East & North Africa (developing only)?
Make the answer very short. 0.68. What is the ratio of the Gross enrolment ratio (%) in Primary schools in Low income to that in Middle East & North Africa (developing only)?
Give a very brief answer. 1.22. What is the ratio of the Gross enrolment ratio (%) of Tertiary schools in Low income to that in Middle East & North Africa (developing only)?
Your answer should be very brief. 1.91. What is the ratio of the Gross enrolment ratio (%) of Pre-primary schools in Low income to that in Middle income?
Provide a succinct answer. 0.64. What is the ratio of the Gross enrolment ratio (%) of Primary schools in Low income to that in Middle income?
Make the answer very short. 2.27. What is the ratio of the Gross enrolment ratio (%) of Secondary schools in Low income to that in Middle income?
Your answer should be very brief. 3.49. What is the ratio of the Gross enrolment ratio (%) in Tertiary schools in Low income to that in Middle income?
Your response must be concise. 8.12. What is the ratio of the Gross enrolment ratio (%) in Pre-primary schools in Lower middle income to that in Middle East & North Africa (all income levels)?
Keep it short and to the point. 1.38. What is the ratio of the Gross enrolment ratio (%) of Primary schools in Lower middle income to that in Middle East & North Africa (all income levels)?
Provide a succinct answer. 1.98. What is the ratio of the Gross enrolment ratio (%) of Secondary schools in Lower middle income to that in Middle East & North Africa (all income levels)?
Provide a short and direct response. 2.13. What is the ratio of the Gross enrolment ratio (%) in Tertiary schools in Lower middle income to that in Middle East & North Africa (all income levels)?
Your answer should be compact. 3.91. What is the ratio of the Gross enrolment ratio (%) in Pre-primary schools in Lower middle income to that in Middle East & North Africa (developing only)?
Your response must be concise. 1.62. What is the ratio of the Gross enrolment ratio (%) in Primary schools in Lower middle income to that in Middle East & North Africa (developing only)?
Offer a very short reply. 1.22. What is the ratio of the Gross enrolment ratio (%) of Secondary schools in Lower middle income to that in Middle East & North Africa (developing only)?
Your answer should be compact. 0.9. What is the ratio of the Gross enrolment ratio (%) of Tertiary schools in Lower middle income to that in Middle East & North Africa (developing only)?
Ensure brevity in your answer.  1.56. What is the ratio of the Gross enrolment ratio (%) of Pre-primary schools in Lower middle income to that in Middle income?
Offer a very short reply. 1.51. What is the ratio of the Gross enrolment ratio (%) of Primary schools in Lower middle income to that in Middle income?
Make the answer very short. 2.27. What is the ratio of the Gross enrolment ratio (%) of Secondary schools in Lower middle income to that in Middle income?
Offer a very short reply. 3.17. What is the ratio of the Gross enrolment ratio (%) in Tertiary schools in Lower middle income to that in Middle income?
Offer a very short reply. 6.65. What is the ratio of the Gross enrolment ratio (%) in Pre-primary schools in Middle East & North Africa (all income levels) to that in Middle East & North Africa (developing only)?
Offer a terse response. 1.17. What is the ratio of the Gross enrolment ratio (%) in Primary schools in Middle East & North Africa (all income levels) to that in Middle East & North Africa (developing only)?
Provide a succinct answer. 0.62. What is the ratio of the Gross enrolment ratio (%) in Secondary schools in Middle East & North Africa (all income levels) to that in Middle East & North Africa (developing only)?
Offer a very short reply. 0.42. What is the ratio of the Gross enrolment ratio (%) in Tertiary schools in Middle East & North Africa (all income levels) to that in Middle East & North Africa (developing only)?
Ensure brevity in your answer.  0.4. What is the ratio of the Gross enrolment ratio (%) in Pre-primary schools in Middle East & North Africa (all income levels) to that in Middle income?
Your response must be concise. 1.1. What is the ratio of the Gross enrolment ratio (%) of Primary schools in Middle East & North Africa (all income levels) to that in Middle income?
Make the answer very short. 1.15. What is the ratio of the Gross enrolment ratio (%) of Secondary schools in Middle East & North Africa (all income levels) to that in Middle income?
Keep it short and to the point. 1.49. What is the ratio of the Gross enrolment ratio (%) of Tertiary schools in Middle East & North Africa (all income levels) to that in Middle income?
Keep it short and to the point. 1.7. What is the ratio of the Gross enrolment ratio (%) in Pre-primary schools in Middle East & North Africa (developing only) to that in Middle income?
Offer a terse response. 0.93. What is the ratio of the Gross enrolment ratio (%) in Primary schools in Middle East & North Africa (developing only) to that in Middle income?
Your response must be concise. 1.86. What is the ratio of the Gross enrolment ratio (%) of Secondary schools in Middle East & North Africa (developing only) to that in Middle income?
Ensure brevity in your answer.  3.51. What is the ratio of the Gross enrolment ratio (%) in Tertiary schools in Middle East & North Africa (developing only) to that in Middle income?
Offer a very short reply. 4.26. What is the difference between the highest and the second highest Gross enrolment ratio (%) in Pre-primary schools?
Your answer should be very brief. 3.22. What is the difference between the highest and the second highest Gross enrolment ratio (%) of Primary schools?
Provide a succinct answer. 0.17. What is the difference between the highest and the second highest Gross enrolment ratio (%) of Secondary schools?
Give a very brief answer. 47.35. What is the difference between the highest and the second highest Gross enrolment ratio (%) of Tertiary schools?
Ensure brevity in your answer.  19.2. What is the difference between the highest and the lowest Gross enrolment ratio (%) of Pre-primary schools?
Ensure brevity in your answer.  6.77. What is the difference between the highest and the lowest Gross enrolment ratio (%) of Primary schools?
Offer a terse response. 59.68. What is the difference between the highest and the lowest Gross enrolment ratio (%) in Secondary schools?
Your answer should be very brief. 70.26. What is the difference between the highest and the lowest Gross enrolment ratio (%) in Tertiary schools?
Provide a short and direct response. 26.1. 